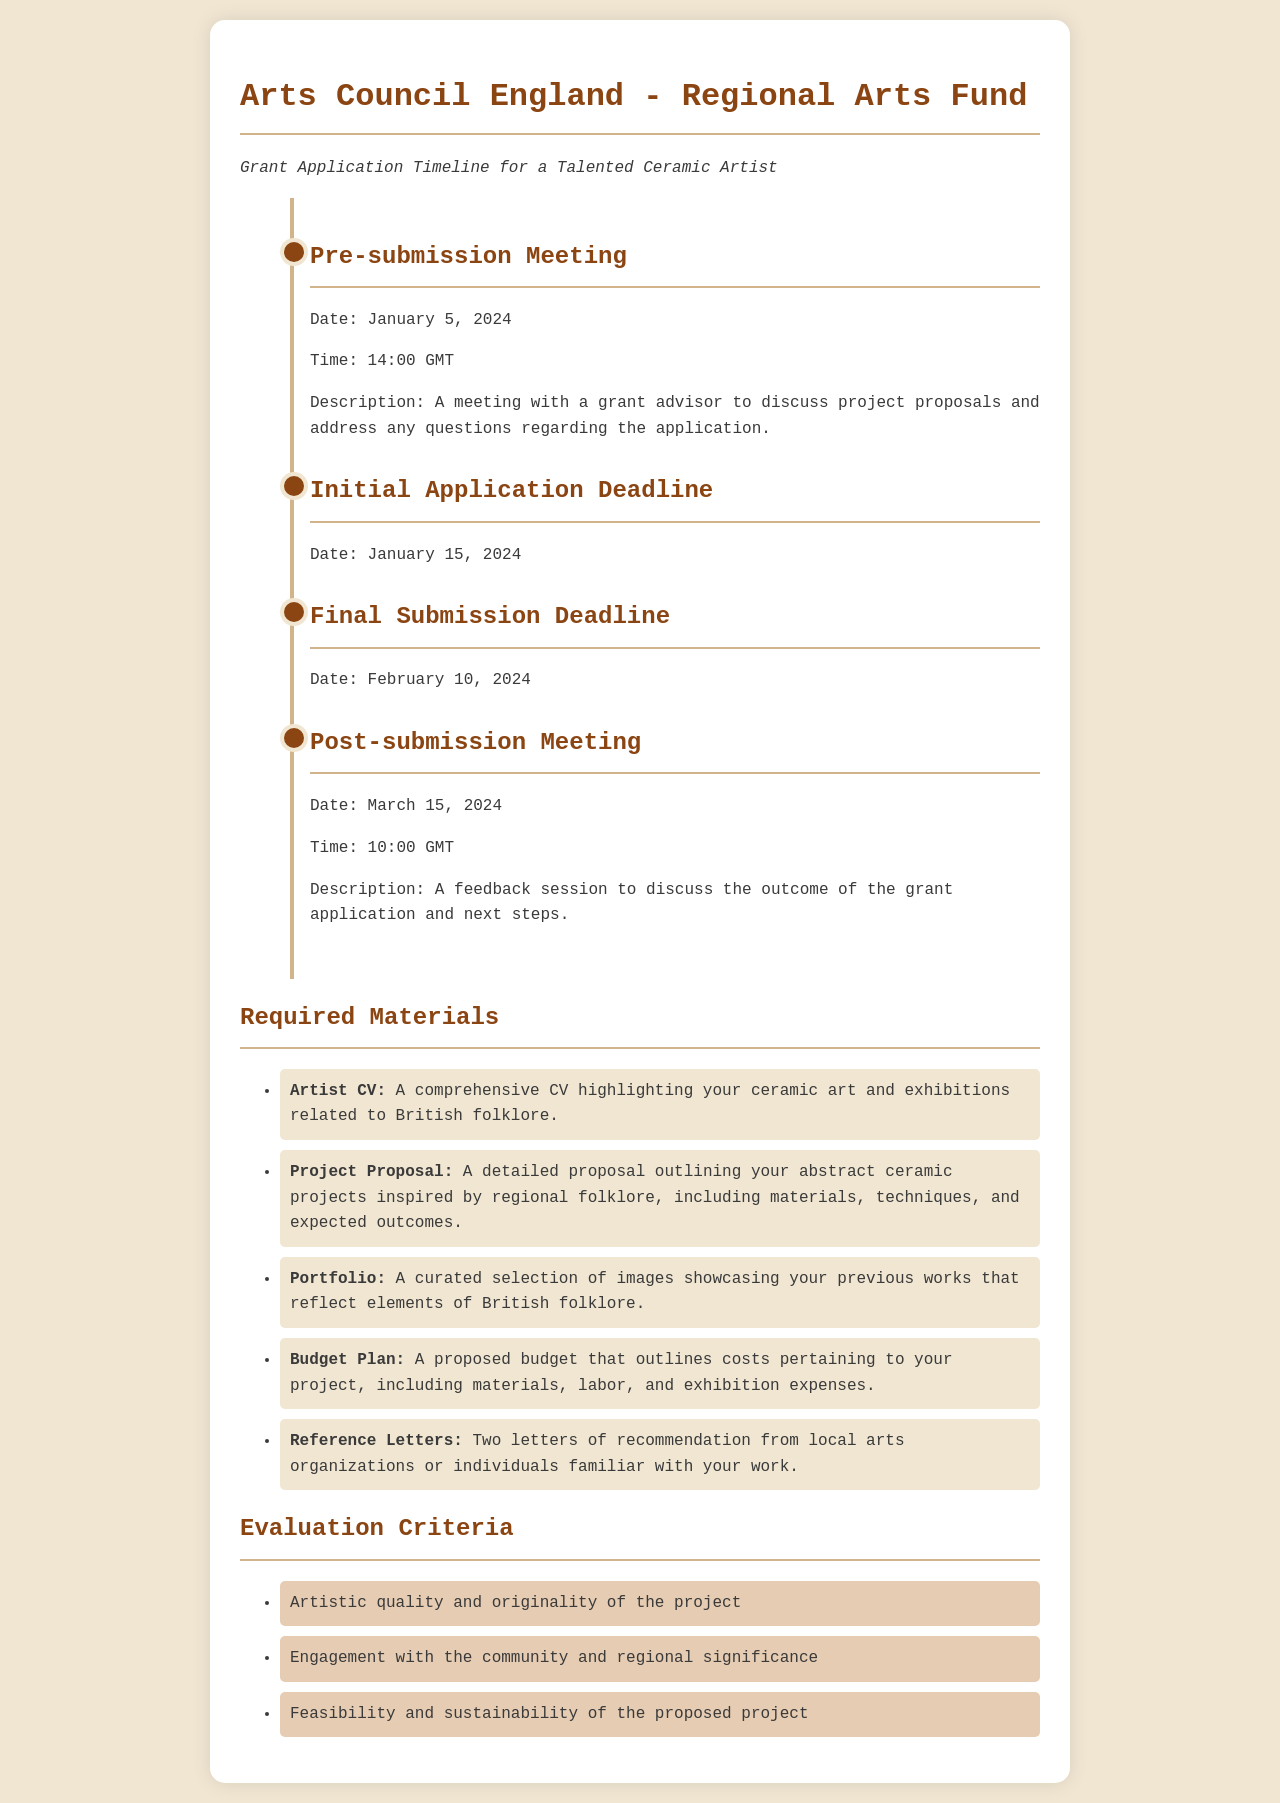What is the date of the Pre-submission Meeting? The date listed in the document for the Pre-submission Meeting is January 5, 2024.
Answer: January 5, 2024 What time is the Post-submission Meeting scheduled? The time for the Post-submission Meeting, as mentioned in the document, is 10:00 GMT.
Answer: 10:00 GMT How many letters of recommendation are required? The document specifies that two letters of recommendation are required.
Answer: Two What is the deadline for the Final Submission? The Final Submission Deadline is indicated as February 10, 2024 in the document.
Answer: February 10, 2024 What is one of the evaluation criteria listed? The document states that one of the evaluation criteria is "Artistic quality and originality of the project."
Answer: Artistic quality and originality of the project What is the focus of the Project Proposal? The Project Proposal must outline abstract ceramic projects inspired by regional folklore, as outlined in the document.
Answer: Abstract ceramic projects inspired by regional folklore What materials need to be included in the application? The required materials include an Artist CV, Project Proposal, Portfolio, Budget Plan, and Reference Letters.
Answer: Artist CV, Project Proposal, Portfolio, Budget Plan, Reference Letters When is the Initial Application Deadline? The Initial Application Deadline is specified in the document as January 15, 2024.
Answer: January 15, 2024 